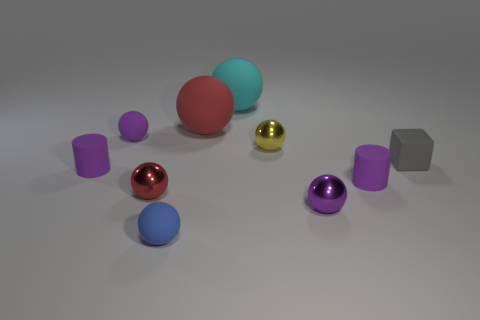There is a red object that is behind the small gray block; what shape is it?
Give a very brief answer. Sphere. What shape is the purple thing behind the purple rubber cylinder that is left of the purple sphere that is in front of the cube?
Your answer should be very brief. Sphere. What number of objects are large cyan spheres or tiny metal things?
Your answer should be very brief. 4. There is a purple matte thing to the right of the tiny yellow sphere; is its shape the same as the purple object that is behind the small gray thing?
Your answer should be compact. No. How many balls are behind the tiny gray object and in front of the big red matte thing?
Your answer should be compact. 2. How many other things are the same size as the red metallic object?
Offer a very short reply. 7. There is a tiny sphere that is both behind the gray rubber cube and to the left of the big cyan ball; what is it made of?
Provide a succinct answer. Rubber. There is a tiny cube; is its color the same as the tiny matte ball that is in front of the small gray object?
Provide a succinct answer. No. The cyan matte thing that is the same shape as the yellow object is what size?
Offer a very short reply. Large. What shape is the object that is both in front of the tiny red sphere and right of the yellow metal ball?
Make the answer very short. Sphere. 